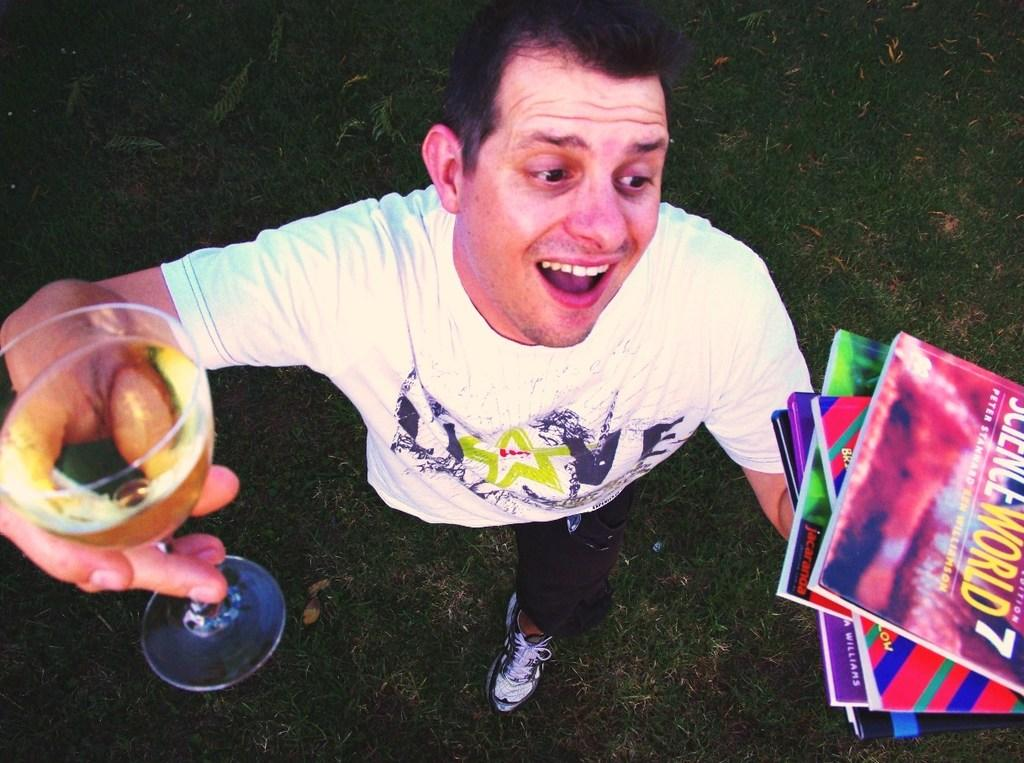Who is present in the image? There is a man in the image. What is the man standing on? The man is standing on the grass. What is the man holding in his hand? The man is holding a glass with liquid in his hand and books in his other hand. What type of tax is being discussed in the image? There is no mention of tax or any discussion in the image; it simply shows a man standing on the grass holding a glass and books. 